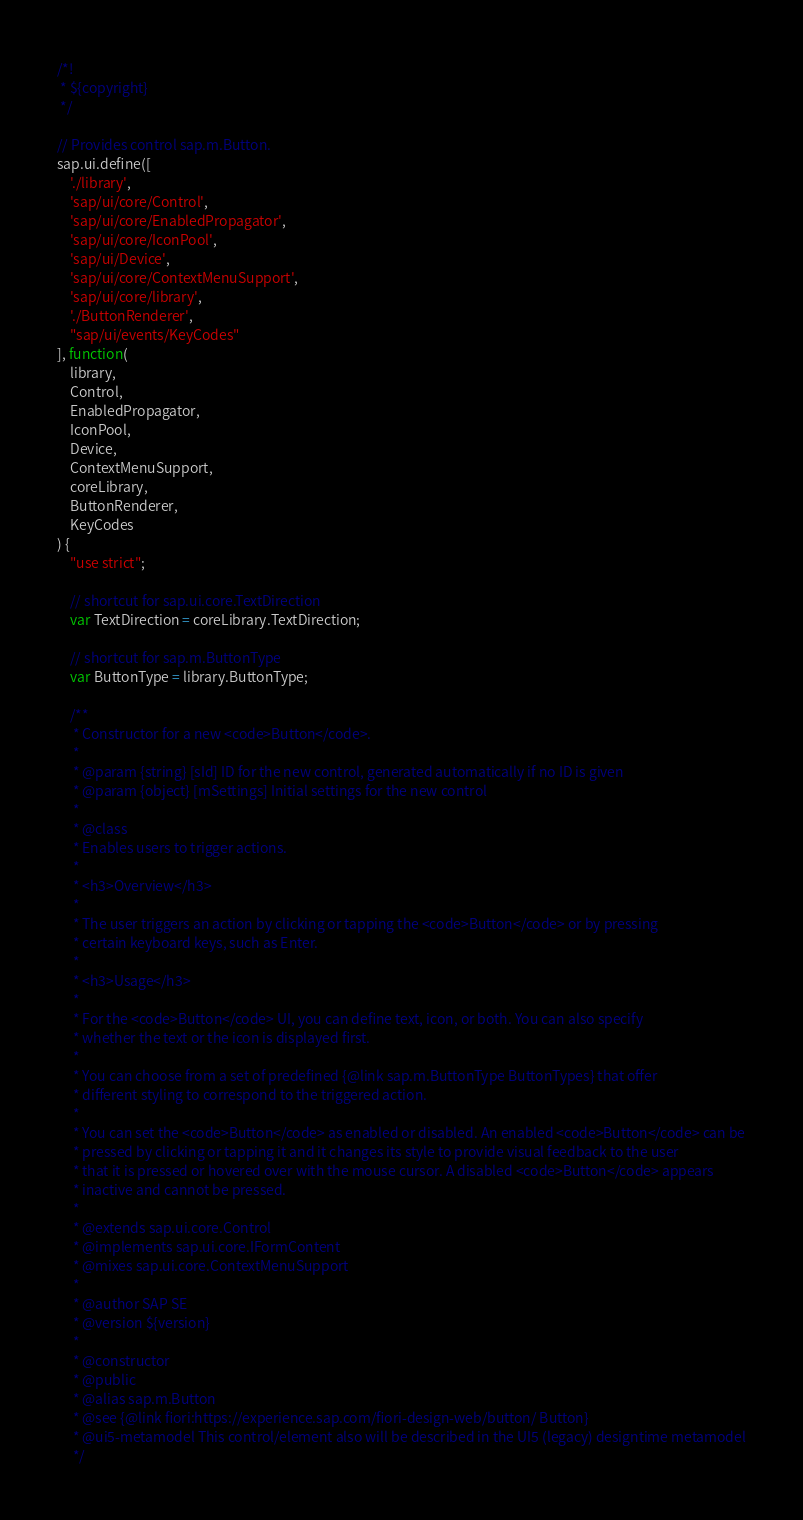Convert code to text. <code><loc_0><loc_0><loc_500><loc_500><_JavaScript_>/*!
 * ${copyright}
 */

// Provides control sap.m.Button.
sap.ui.define([
	'./library',
	'sap/ui/core/Control',
	'sap/ui/core/EnabledPropagator',
	'sap/ui/core/IconPool',
	'sap/ui/Device',
	'sap/ui/core/ContextMenuSupport',
	'sap/ui/core/library',
	'./ButtonRenderer',
	"sap/ui/events/KeyCodes"
], function(
	library,
	Control,
	EnabledPropagator,
	IconPool,
	Device,
	ContextMenuSupport,
	coreLibrary,
	ButtonRenderer,
	KeyCodes
) {
	"use strict";

	// shortcut for sap.ui.core.TextDirection
	var TextDirection = coreLibrary.TextDirection;

	// shortcut for sap.m.ButtonType
	var ButtonType = library.ButtonType;

	/**
	 * Constructor for a new <code>Button</code>.
	 *
	 * @param {string} [sId] ID for the new control, generated automatically if no ID is given
	 * @param {object} [mSettings] Initial settings for the new control
	 *
	 * @class
	 * Enables users to trigger actions.
	 *
	 * <h3>Overview</h3>
	 *
	 * The user triggers an action by clicking or tapping the <code>Button</code> or by pressing
	 * certain keyboard keys, such as Enter.
	 *
	 * <h3>Usage</h3>
	 *
	 * For the <code>Button</code> UI, you can define text, icon, or both. You can also specify
	 * whether the text or the icon is displayed first.
	 *
	 * You can choose from a set of predefined {@link sap.m.ButtonType ButtonTypes} that offer
	 * different styling to correspond to the triggered action.
	 *
	 * You can set the <code>Button</code> as enabled or disabled. An enabled <code>Button</code> can be
	 * pressed by clicking or tapping it and it changes its style to provide visual feedback to the user
	 * that it is pressed or hovered over with the mouse cursor. A disabled <code>Button</code> appears
	 * inactive and cannot be pressed.
	 *
	 * @extends sap.ui.core.Control
	 * @implements sap.ui.core.IFormContent
	 * @mixes sap.ui.core.ContextMenuSupport
	 *
	 * @author SAP SE
	 * @version ${version}
	 *
	 * @constructor
	 * @public
	 * @alias sap.m.Button
	 * @see {@link fiori:https://experience.sap.com/fiori-design-web/button/ Button}
	 * @ui5-metamodel This control/element also will be described in the UI5 (legacy) designtime metamodel
	 */</code> 